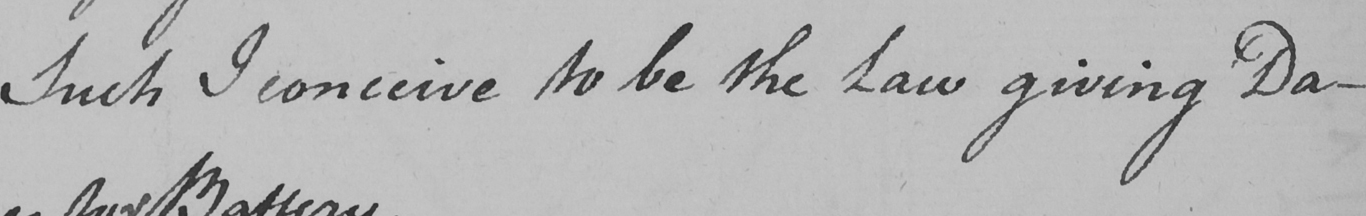Can you tell me what this handwritten text says? Such I conceive to be the Law giving Da- 